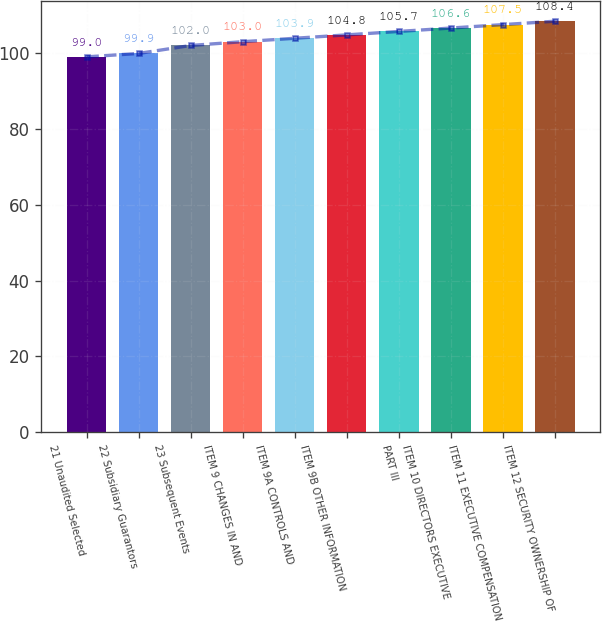Convert chart. <chart><loc_0><loc_0><loc_500><loc_500><bar_chart><fcel>21 Unaudited Selected<fcel>22 Subsidiary Guarantors<fcel>23 Subsequent Events<fcel>ITEM 9 CHANGES IN AND<fcel>ITEM 9A CONTROLS AND<fcel>ITEM 9B OTHER INFORMATION<fcel>PART III<fcel>ITEM 10 DIRECTORS EXECUTIVE<fcel>ITEM 11 EXECUTIVE COMPENSATION<fcel>ITEM 12 SECURITY OWNERSHIP OF<nl><fcel>99<fcel>99.9<fcel>102<fcel>103<fcel>103.9<fcel>104.8<fcel>105.7<fcel>106.6<fcel>107.5<fcel>108.4<nl></chart> 